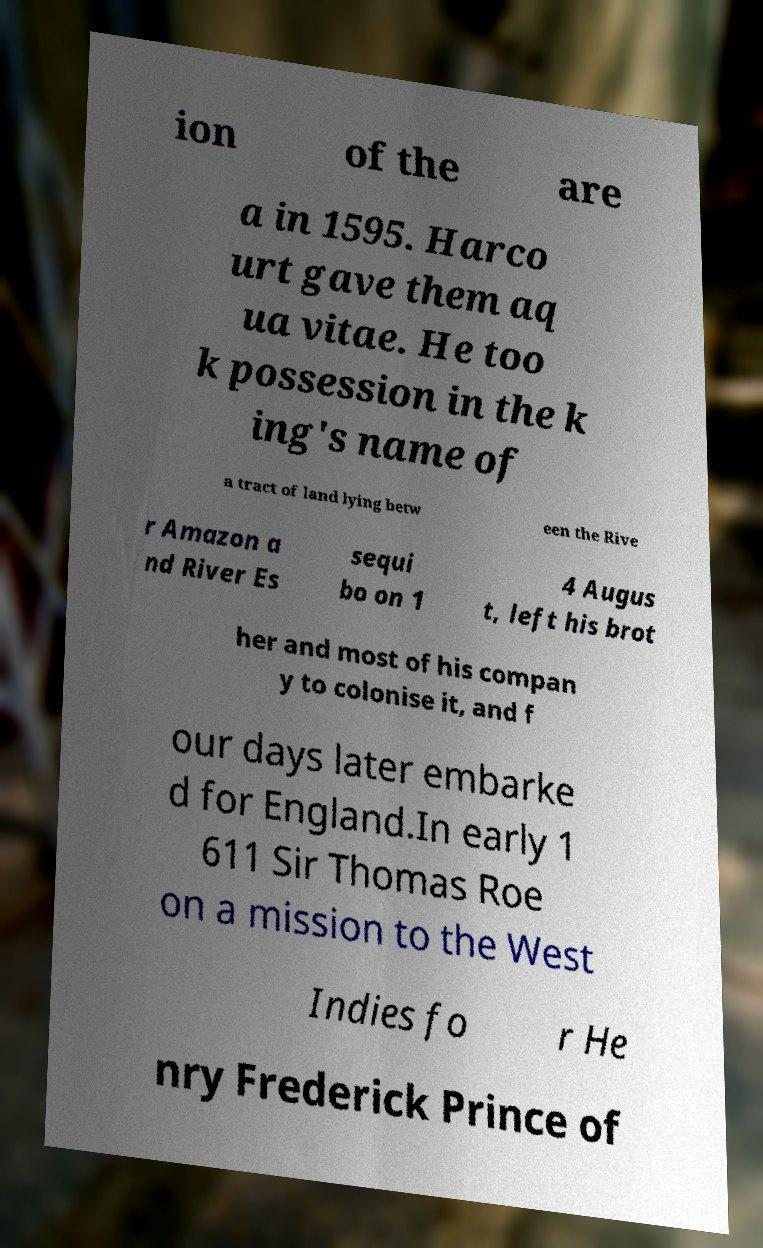Please identify and transcribe the text found in this image. ion of the are a in 1595. Harco urt gave them aq ua vitae. He too k possession in the k ing's name of a tract of land lying betw een the Rive r Amazon a nd River Es sequi bo on 1 4 Augus t, left his brot her and most of his compan y to colonise it, and f our days later embarke d for England.In early 1 611 Sir Thomas Roe on a mission to the West Indies fo r He nry Frederick Prince of 